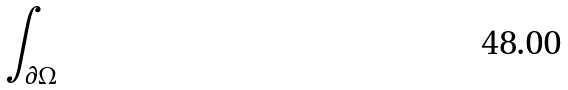<formula> <loc_0><loc_0><loc_500><loc_500>\int _ { \partial \Omega }</formula> 